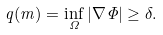Convert formula to latex. <formula><loc_0><loc_0><loc_500><loc_500>q ( m ) = \inf _ { \Omega } | \nabla \Phi | \geq \delta .</formula> 